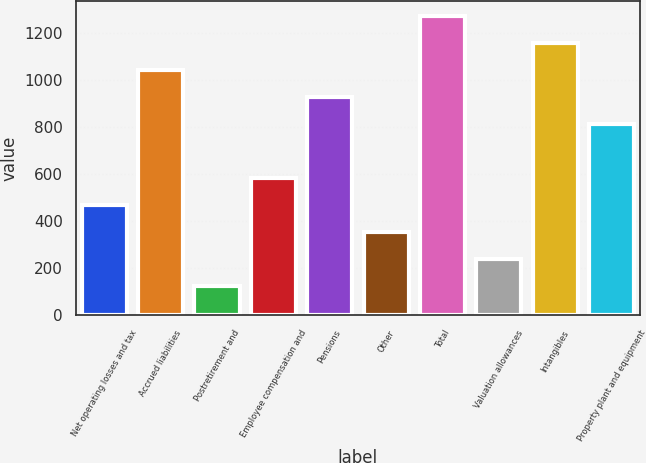Convert chart. <chart><loc_0><loc_0><loc_500><loc_500><bar_chart><fcel>Net operating losses and tax<fcel>Accrued liabilities<fcel>Postretirement and<fcel>Employee compensation and<fcel>Pensions<fcel>Other<fcel>Total<fcel>Valuation allowances<fcel>Intangibles<fcel>Property plant and equipment<nl><fcel>468.6<fcel>1043.1<fcel>123.9<fcel>583.5<fcel>928.2<fcel>353.7<fcel>1272.9<fcel>238.8<fcel>1158<fcel>813.3<nl></chart> 